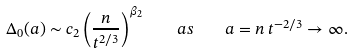Convert formula to latex. <formula><loc_0><loc_0><loc_500><loc_500>\Delta _ { 0 } ( a ) \sim c _ { 2 } \left ( \frac { n } { t ^ { 2 / 3 } } \right ) ^ { \beta _ { 2 } } \quad a s \quad a = n \, t ^ { - 2 / 3 } \to \infty .</formula> 